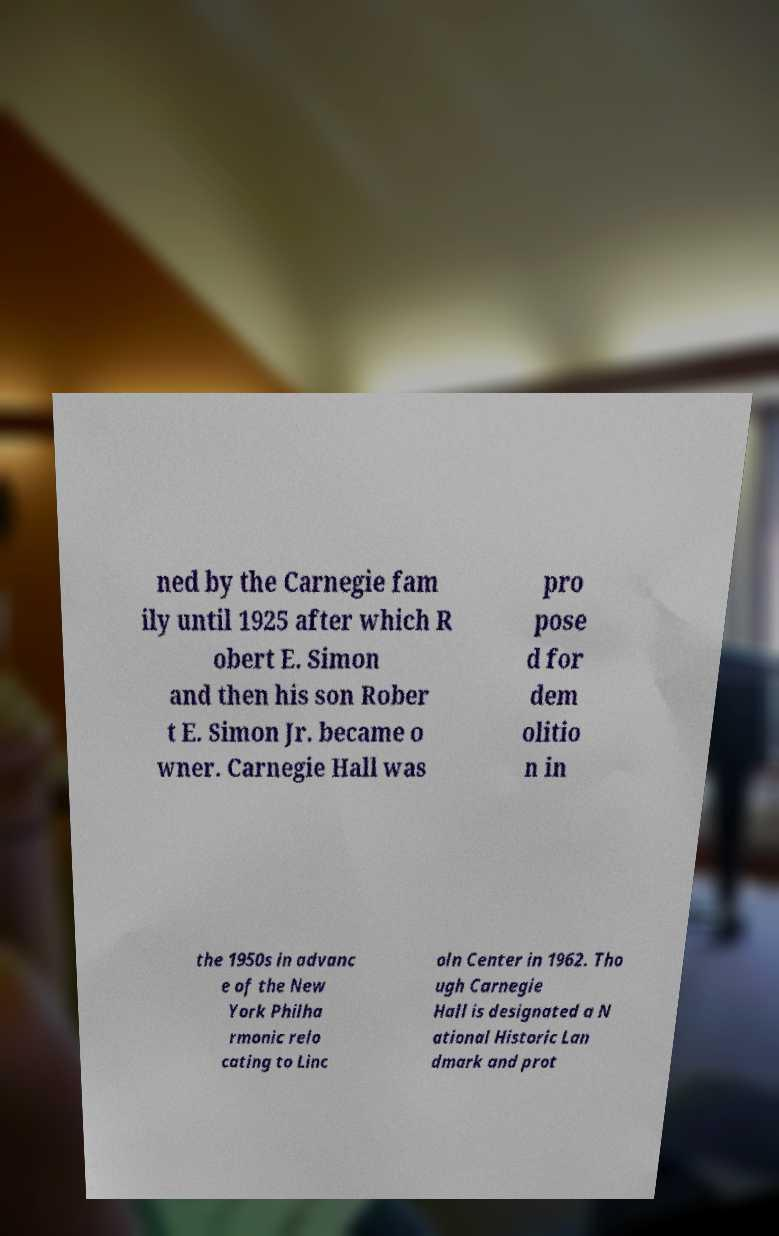Please identify and transcribe the text found in this image. ned by the Carnegie fam ily until 1925 after which R obert E. Simon and then his son Rober t E. Simon Jr. became o wner. Carnegie Hall was pro pose d for dem olitio n in the 1950s in advanc e of the New York Philha rmonic relo cating to Linc oln Center in 1962. Tho ugh Carnegie Hall is designated a N ational Historic Lan dmark and prot 